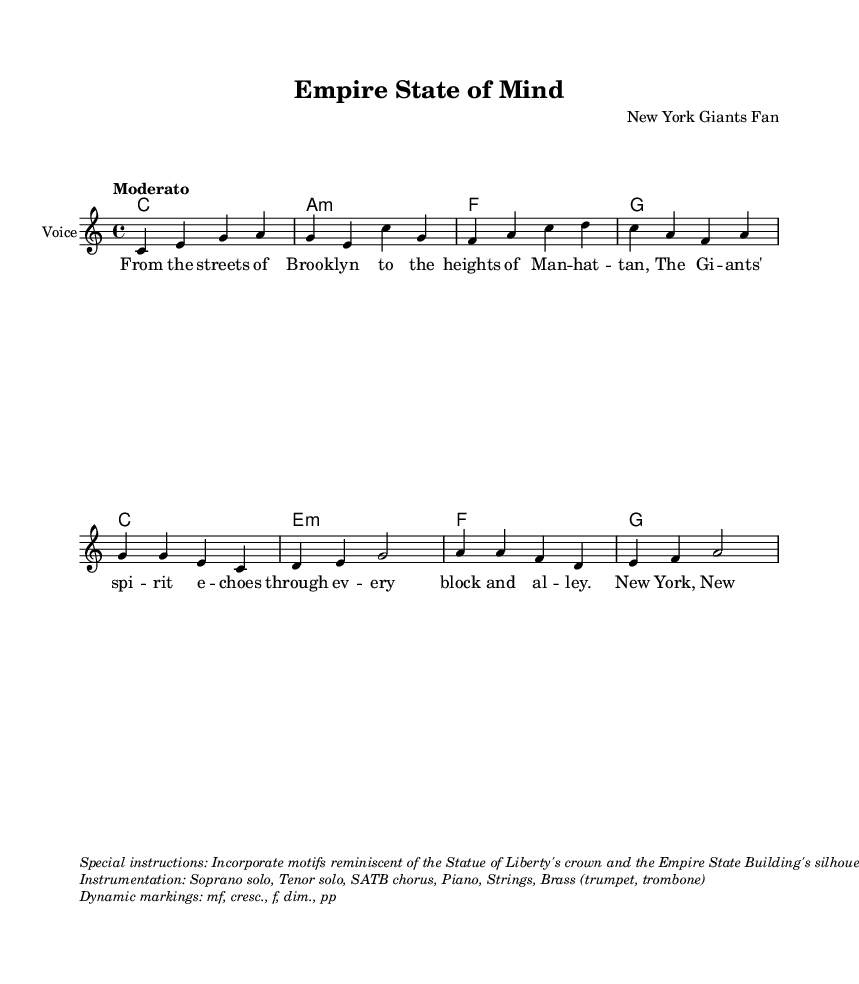What is the key signature of this music? The key signature is C major, which has no sharps or flats, as indicated at the beginning of the score.
Answer: C major What is the time signature of this music? The time signature is 4/4, which means there are four beats in each measure, as stated at the start of the score.
Answer: 4/4 What is the tempo marking for this piece? The tempo marking is "Moderato", suggesting a moderate pace for the performance, as noted in the global settings of the score.
Answer: Moderato How many verses are included in the lyrics? There is one verse included in the lyrics, as the sheet music contains one distinct section labeled as a verse before the chorus.
Answer: One What instruments are specified in the instrumentation? The specified instruments include Soprano solo, Tenor solo, SATB chorus, Piano, Strings, and Brass (trumpet, trombone), as detailed in the markup section.
Answer: Soprano solo, Tenor solo, SATB chorus, Piano, Strings, Brass What thematic motifs should be incorporated into the melody according to the special instructions? The special instructions suggest incorporating motifs reminiscent of the Statue of Liberty's crown and Empire State Building's silhouette, indicating a connection to significant New York landmarks.
Answer: Statue of Liberty's crown, Empire State Building's silhouette 